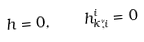<formula> <loc_0><loc_0><loc_500><loc_500>h = 0 , \quad { h ^ { i } _ { k } } _ { \tilde { ; } i } = 0</formula> 